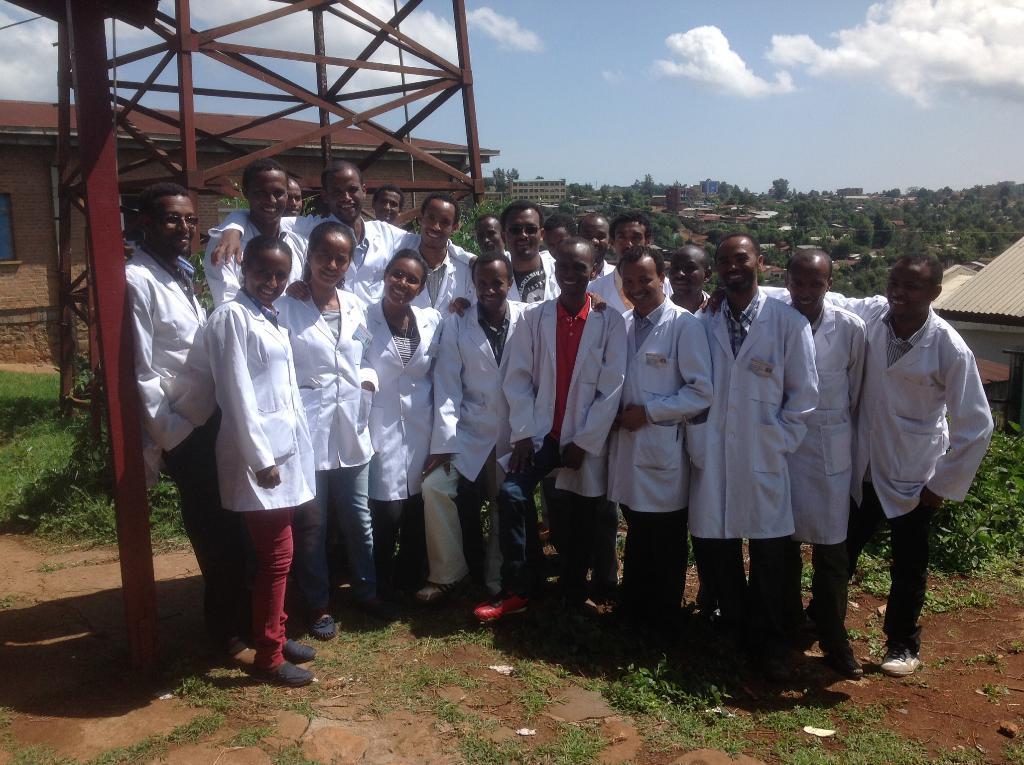Please provide a concise description of this image. In this image we can see two houses, some buildings, some objects on the ground, one wire, one antenna, some trees, bushes, plants and grass on the ground. There are some people with smiling faces wearing white coats and standing on the ground. At the top there is the cloudy sky. 